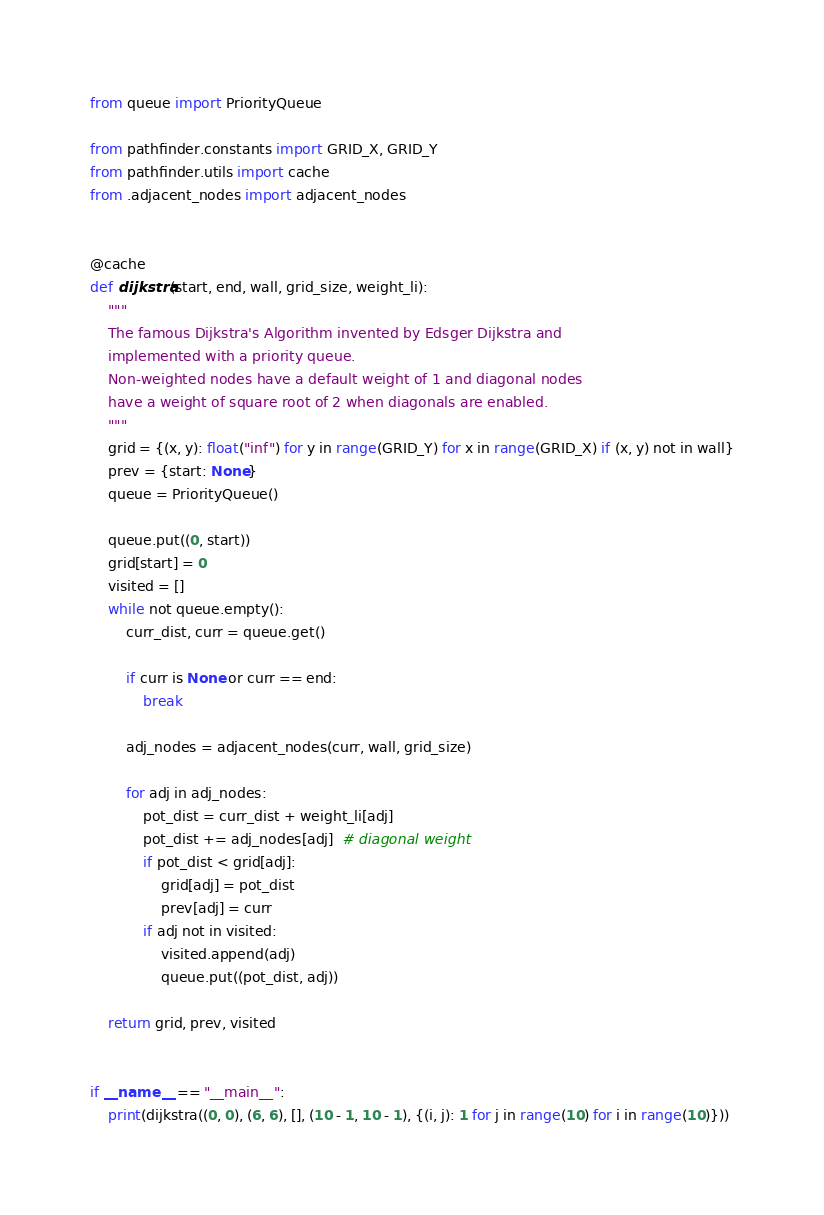Convert code to text. <code><loc_0><loc_0><loc_500><loc_500><_Python_>from queue import PriorityQueue

from pathfinder.constants import GRID_X, GRID_Y
from pathfinder.utils import cache
from .adjacent_nodes import adjacent_nodes


@cache
def dijkstra(start, end, wall, grid_size, weight_li):
    """
    The famous Dijkstra's Algorithm invented by Edsger Dijkstra and
    implemented with a priority queue.
    Non-weighted nodes have a default weight of 1 and diagonal nodes
    have a weight of square root of 2 when diagonals are enabled.
    """
    grid = {(x, y): float("inf") for y in range(GRID_Y) for x in range(GRID_X) if (x, y) not in wall}
    prev = {start: None}
    queue = PriorityQueue()

    queue.put((0, start))
    grid[start] = 0
    visited = []
    while not queue.empty():
        curr_dist, curr = queue.get()

        if curr is None or curr == end:
            break

        adj_nodes = adjacent_nodes(curr, wall, grid_size)

        for adj in adj_nodes:
            pot_dist = curr_dist + weight_li[adj]
            pot_dist += adj_nodes[adj]  # diagonal weight
            if pot_dist < grid[adj]:
                grid[adj] = pot_dist
                prev[adj] = curr
            if adj not in visited:
                visited.append(adj)
                queue.put((pot_dist, adj))

    return grid, prev, visited


if __name__ == "__main__":
    print(dijkstra((0, 0), (6, 6), [], (10 - 1, 10 - 1), {(i, j): 1 for j in range(10) for i in range(10)}))
</code> 